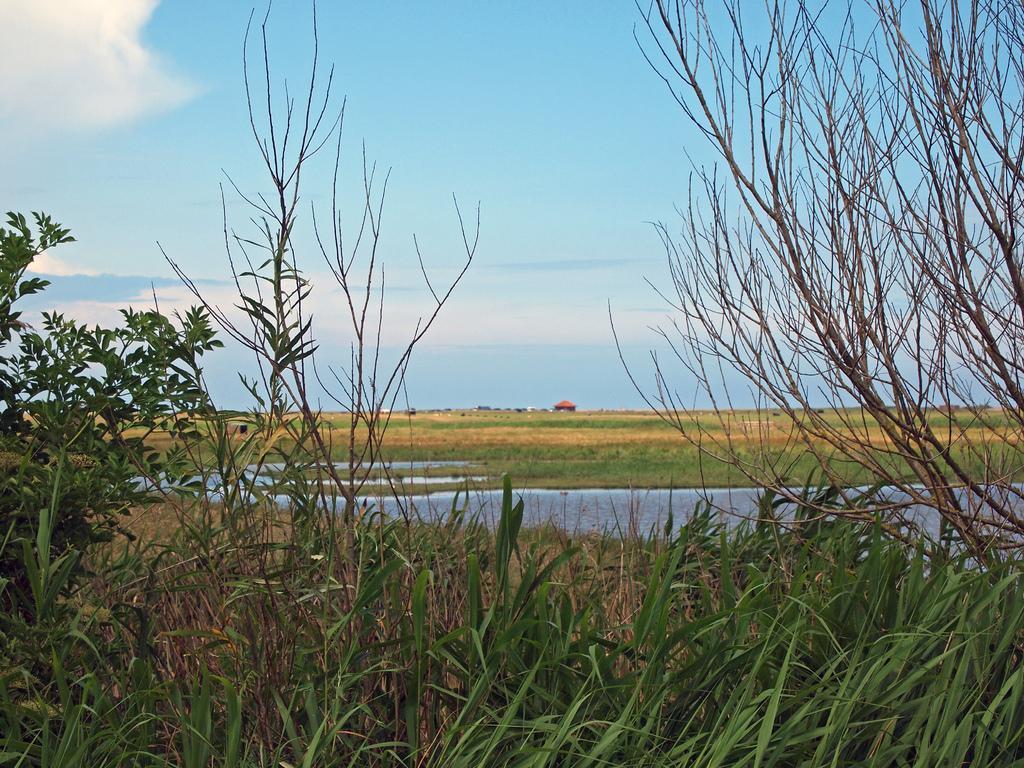Could you give a brief overview of what you see in this image? In this image we can see grass, trees and the sky with clouds in the background. 